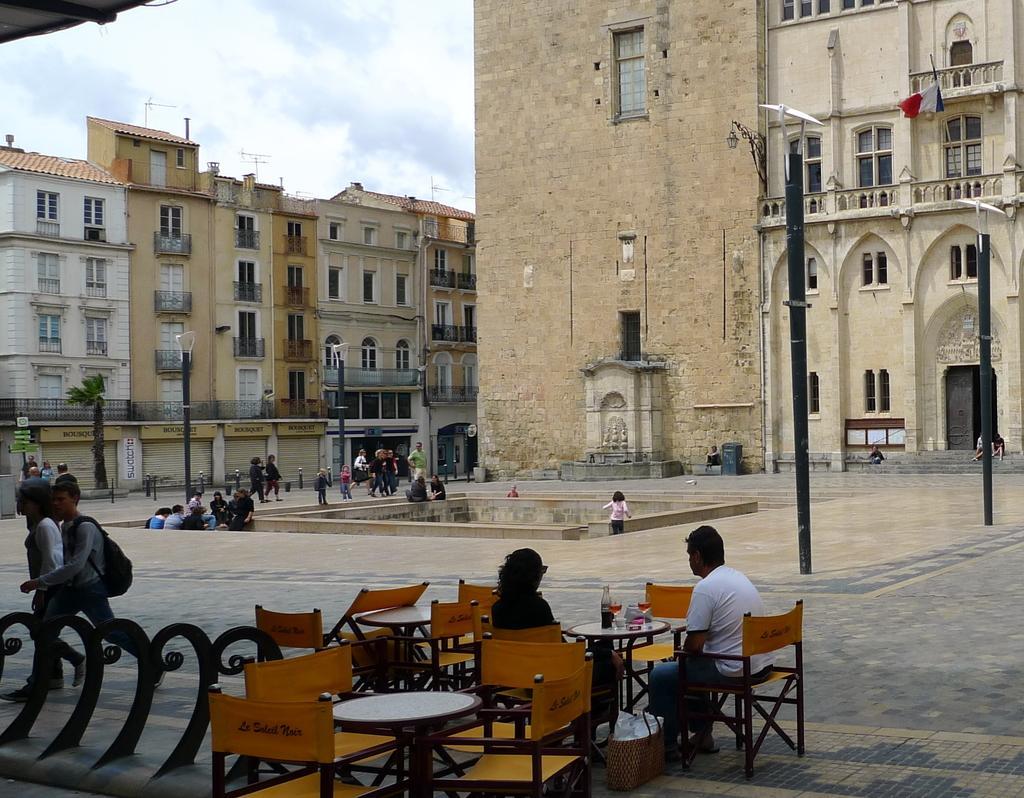Can you describe this image briefly? As we can see in the image, there is a sky, buildings, few people standing and walking on road and there are chairs and tables over here. 